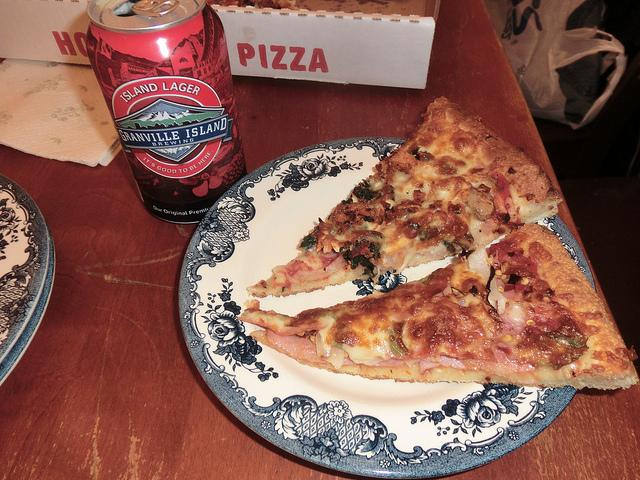What kind of beverage is being enjoyed with the pizza?

Choices:
A) soda
B) beer
C) vodka
D) juice beer 